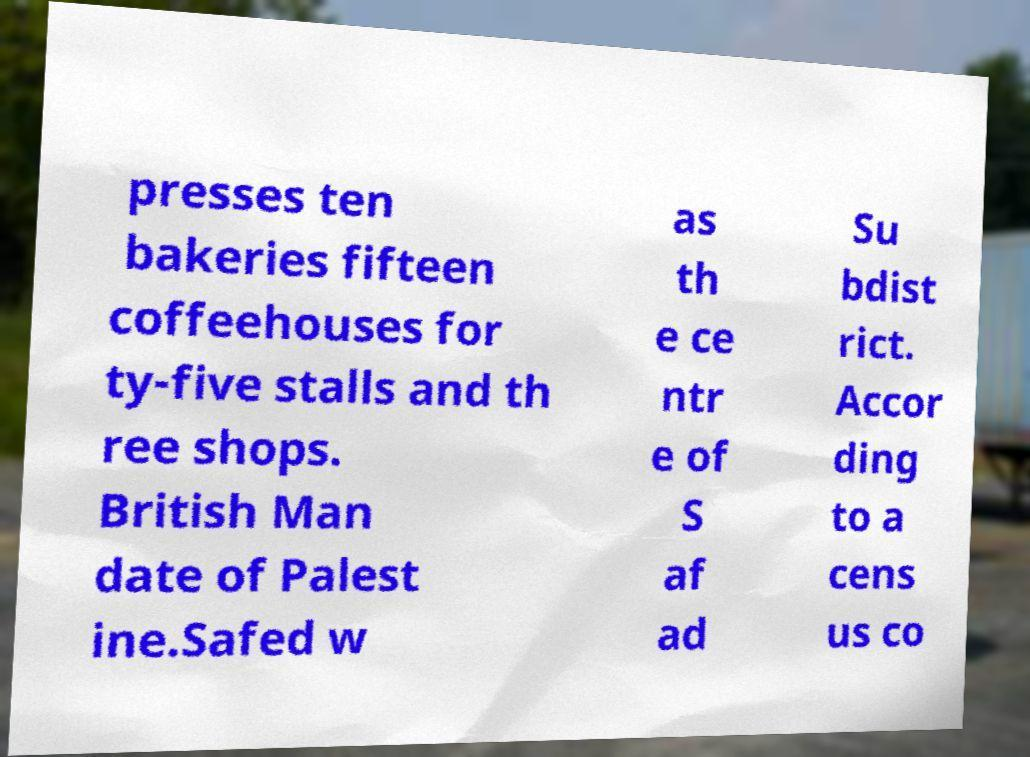Could you extract and type out the text from this image? presses ten bakeries fifteen coffeehouses for ty-five stalls and th ree shops. British Man date of Palest ine.Safed w as th e ce ntr e of S af ad Su bdist rict. Accor ding to a cens us co 